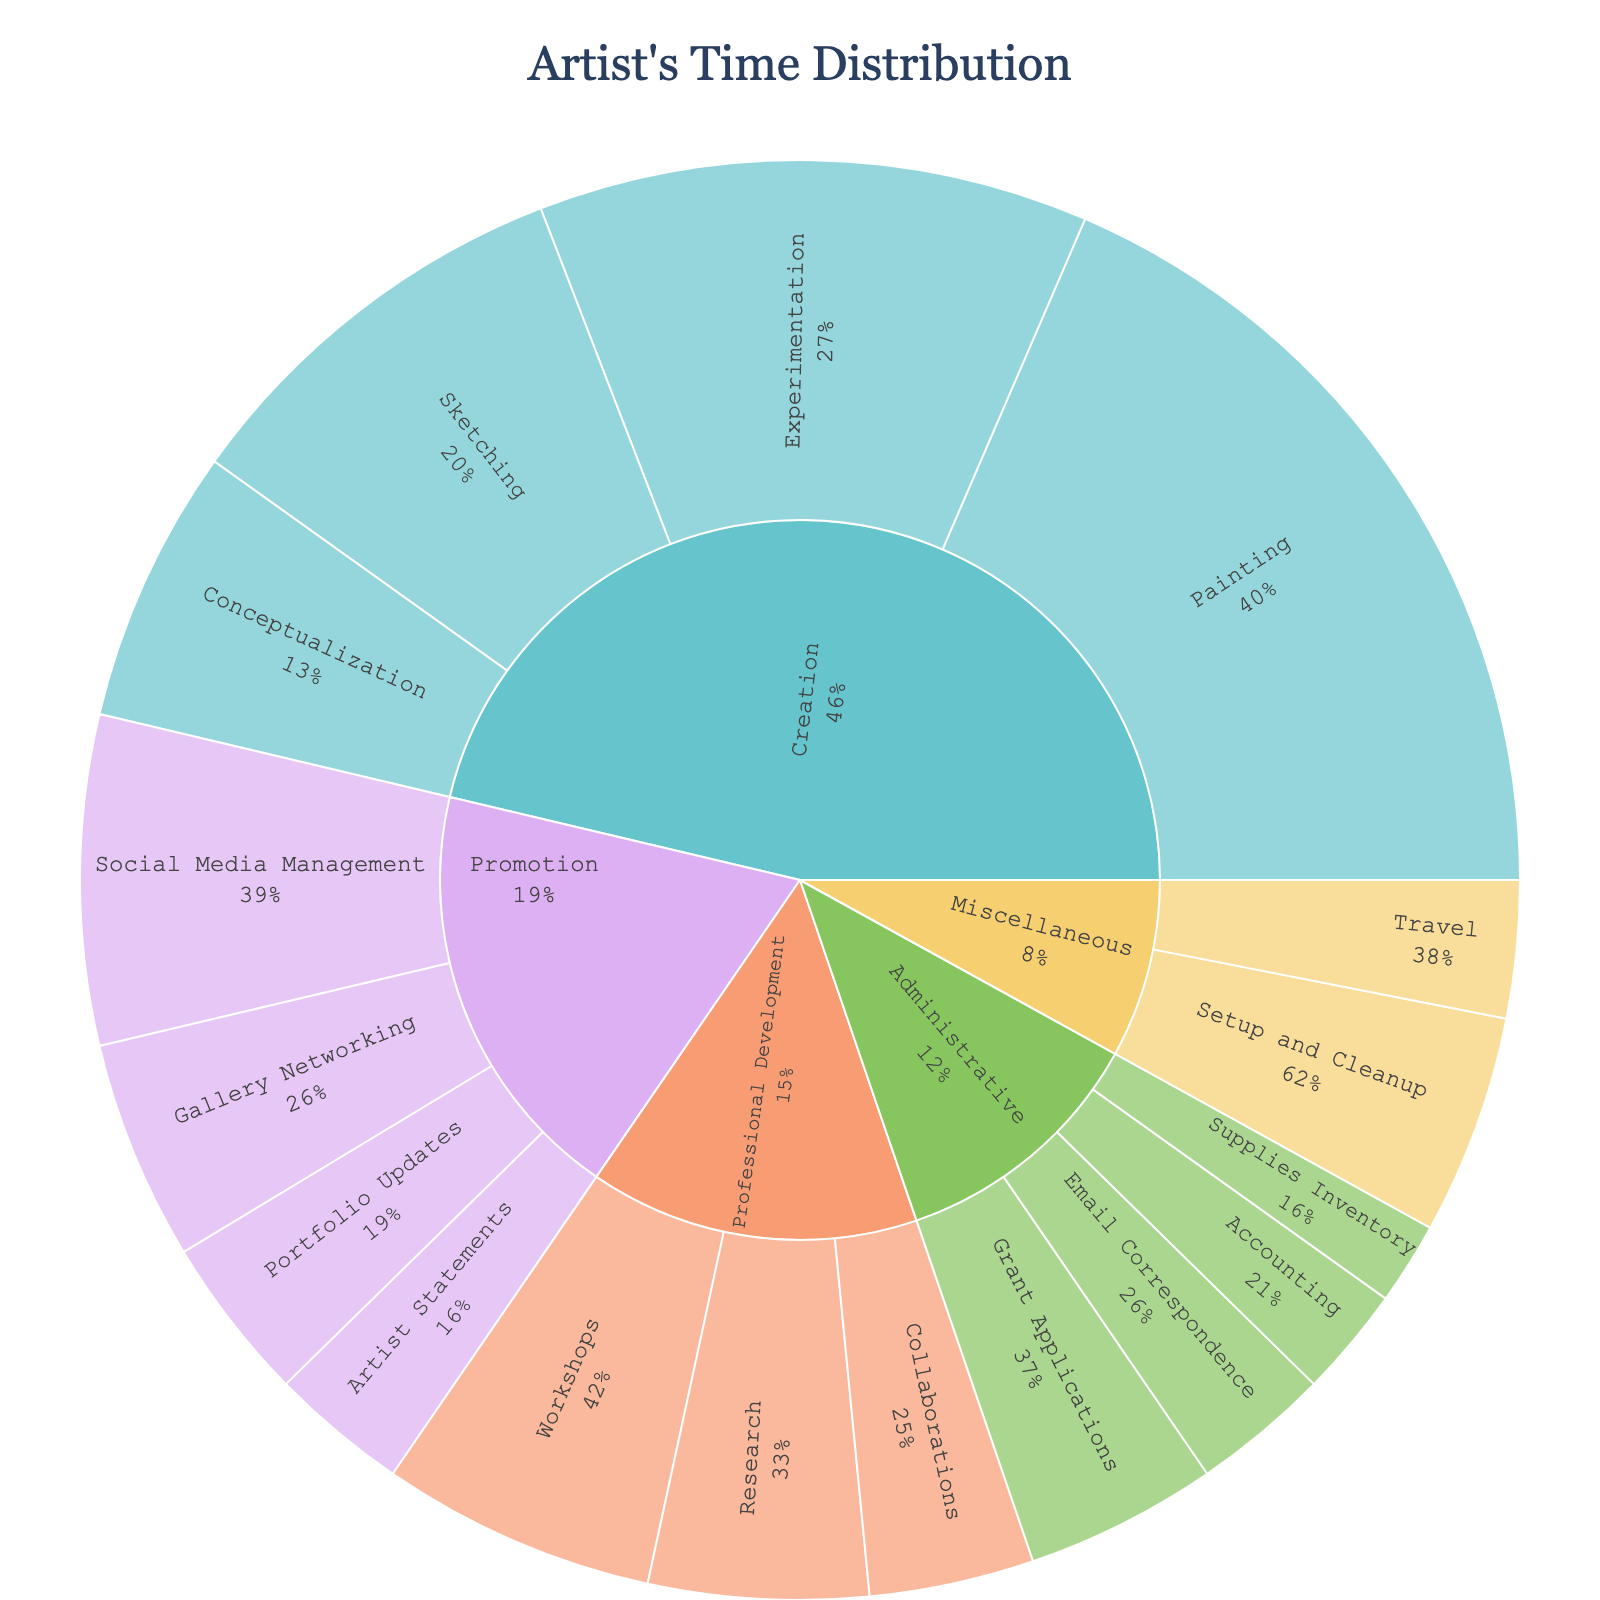What is the title of the plot? The title is prominently displayed at the top center of the plot.
Answer: Artist's Time Distribution Which category has the largest share of time? Observe the area size and percentage of each category relative to the center of the plot.
Answer: Creation How many hours are spent on Sketching? Look at the hover data or the label corresponding to Sketching.
Answer: 15 hours What percentage of time is spent on Social Media Management relative to Promotion? Find the percentage labeled on the Social Media Management section within the Promotion category.
Answer: Around 24% How much total time is spent on Professional Development? Sum the hours for all subcategories under Professional Development: Workshops (10) + Research (8) + Collaborations (6).
Answer: 24 hours Which subcategory under Administrative takes the least amount of time? Compare the labels and hours for subcategories under Administrative.
Answer: Supplies Inventory Is more time spent on Social Media Management or Gallery Networking? Compare the labeled hours for Social Media Management and Gallery Networking under Promotion.
Answer: Social Media Management What is the total time dedicated to Experimentation and Conceptualization? Add the hours for Experimentation (20) and Conceptualization (10) under Creation.
Answer: 30 hours How does the time spent on Email Correspondence compare to Grant Applications? Look at the labeled hours for Email Correspondence and Grant Applications under Administrative.
Answer: Email Correspondence is less Which aspect of an artist's career has more subcategories, Promotion or Miscellaneous? Count the number of subcategories under each category and compare.
Answer: Promotion 